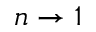<formula> <loc_0><loc_0><loc_500><loc_500>n \rightarrow 1</formula> 